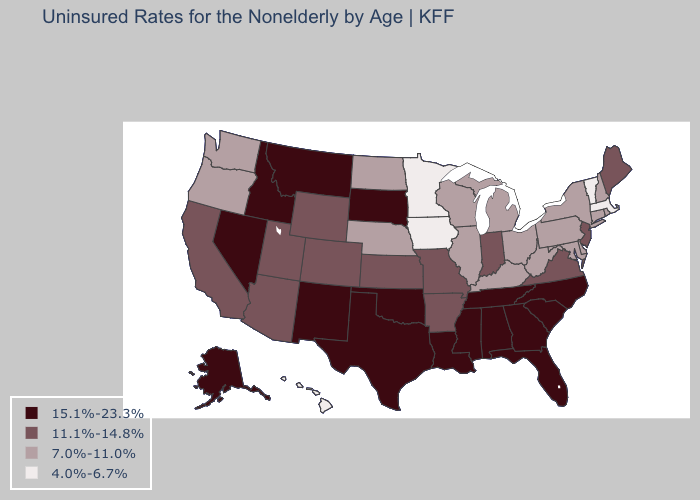Which states have the lowest value in the South?
Write a very short answer. Delaware, Kentucky, Maryland, West Virginia. Does Oklahoma have the highest value in the USA?
Quick response, please. Yes. What is the lowest value in the USA?
Write a very short answer. 4.0%-6.7%. Does Idaho have the same value as New Mexico?
Keep it brief. Yes. What is the value of Oklahoma?
Concise answer only. 15.1%-23.3%. What is the highest value in states that border Missouri?
Write a very short answer. 15.1%-23.3%. Name the states that have a value in the range 15.1%-23.3%?
Be succinct. Alabama, Alaska, Florida, Georgia, Idaho, Louisiana, Mississippi, Montana, Nevada, New Mexico, North Carolina, Oklahoma, South Carolina, South Dakota, Tennessee, Texas. Name the states that have a value in the range 15.1%-23.3%?
Give a very brief answer. Alabama, Alaska, Florida, Georgia, Idaho, Louisiana, Mississippi, Montana, Nevada, New Mexico, North Carolina, Oklahoma, South Carolina, South Dakota, Tennessee, Texas. What is the value of Virginia?
Quick response, please. 11.1%-14.8%. What is the value of California?
Write a very short answer. 11.1%-14.8%. Name the states that have a value in the range 4.0%-6.7%?
Short answer required. Hawaii, Iowa, Massachusetts, Minnesota, Vermont. Does Florida have the same value as Oregon?
Concise answer only. No. Name the states that have a value in the range 15.1%-23.3%?
Short answer required. Alabama, Alaska, Florida, Georgia, Idaho, Louisiana, Mississippi, Montana, Nevada, New Mexico, North Carolina, Oklahoma, South Carolina, South Dakota, Tennessee, Texas. Which states hav the highest value in the South?
Quick response, please. Alabama, Florida, Georgia, Louisiana, Mississippi, North Carolina, Oklahoma, South Carolina, Tennessee, Texas. Name the states that have a value in the range 15.1%-23.3%?
Concise answer only. Alabama, Alaska, Florida, Georgia, Idaho, Louisiana, Mississippi, Montana, Nevada, New Mexico, North Carolina, Oklahoma, South Carolina, South Dakota, Tennessee, Texas. 